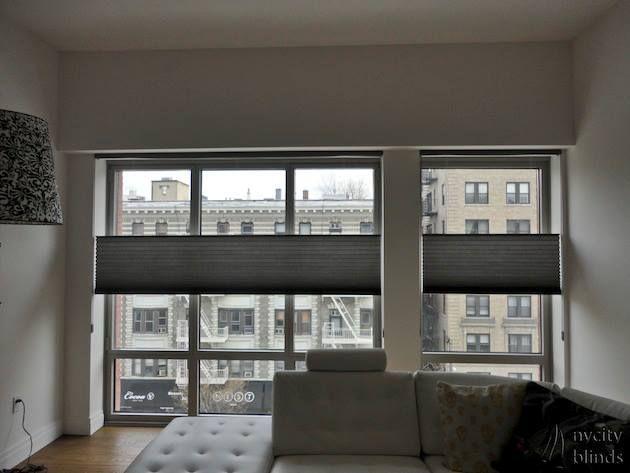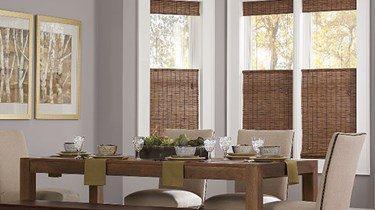The first image is the image on the left, the second image is the image on the right. For the images displayed, is the sentence "There are buildings visible through the windows." factually correct? Answer yes or no. Yes. The first image is the image on the left, the second image is the image on the right. Examine the images to the left and right. Is the description "One image shows a tufted couch in front of a wide paned window on the left and a narrower window on the right, all with gray shades that don't cover the window tops." accurate? Answer yes or no. Yes. 